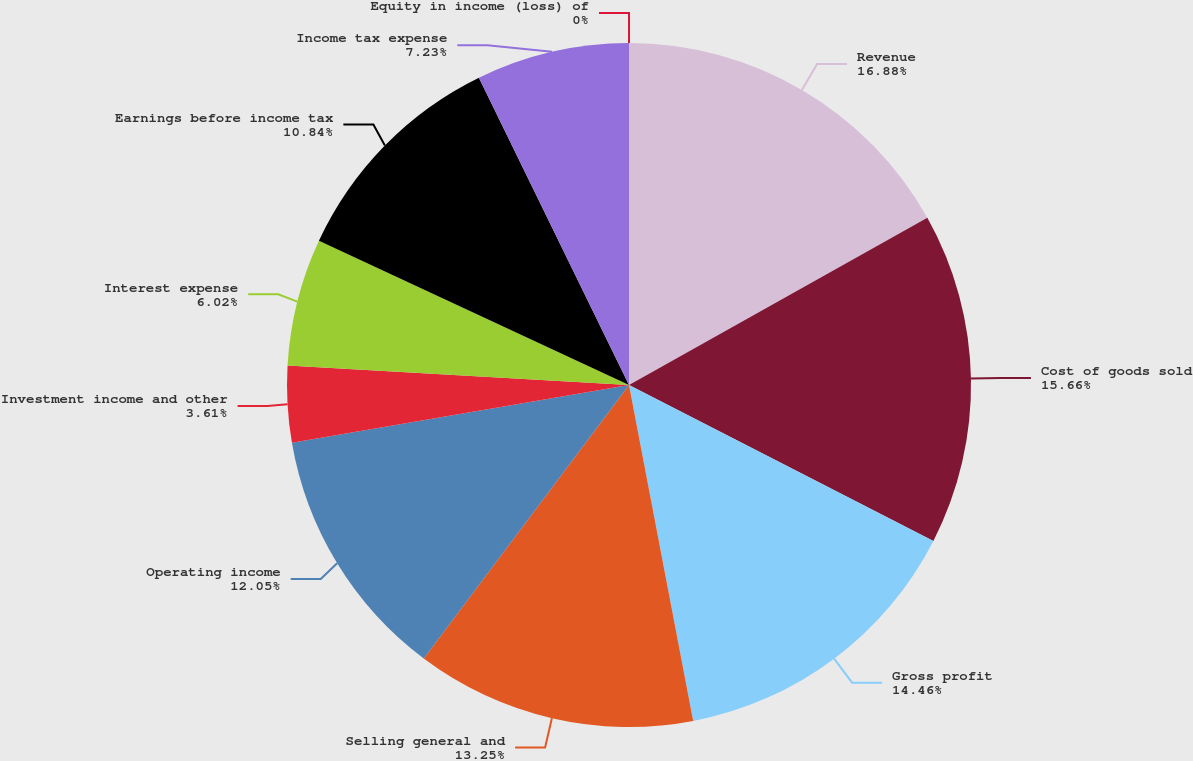Convert chart to OTSL. <chart><loc_0><loc_0><loc_500><loc_500><pie_chart><fcel>Revenue<fcel>Cost of goods sold<fcel>Gross profit<fcel>Selling general and<fcel>Operating income<fcel>Investment income and other<fcel>Interest expense<fcel>Earnings before income tax<fcel>Income tax expense<fcel>Equity in income (loss) of<nl><fcel>16.87%<fcel>15.66%<fcel>14.46%<fcel>13.25%<fcel>12.05%<fcel>3.61%<fcel>6.02%<fcel>10.84%<fcel>7.23%<fcel>0.0%<nl></chart> 